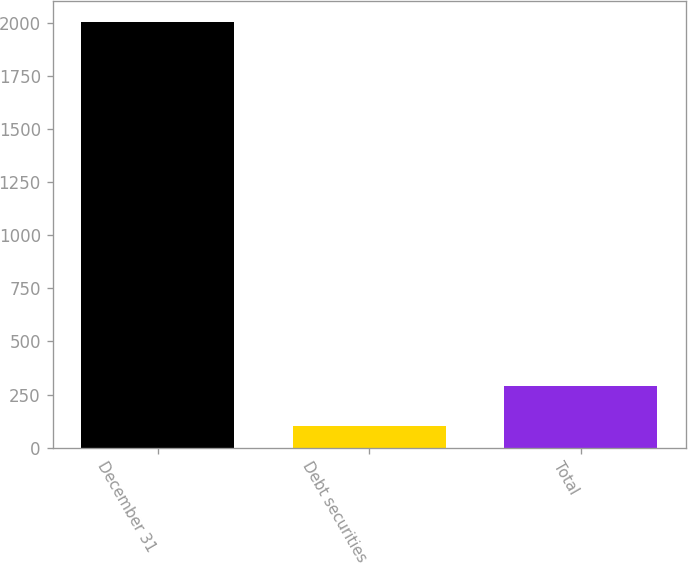Convert chart to OTSL. <chart><loc_0><loc_0><loc_500><loc_500><bar_chart><fcel>December 31<fcel>Debt securities<fcel>Total<nl><fcel>2004<fcel>100<fcel>290.4<nl></chart> 